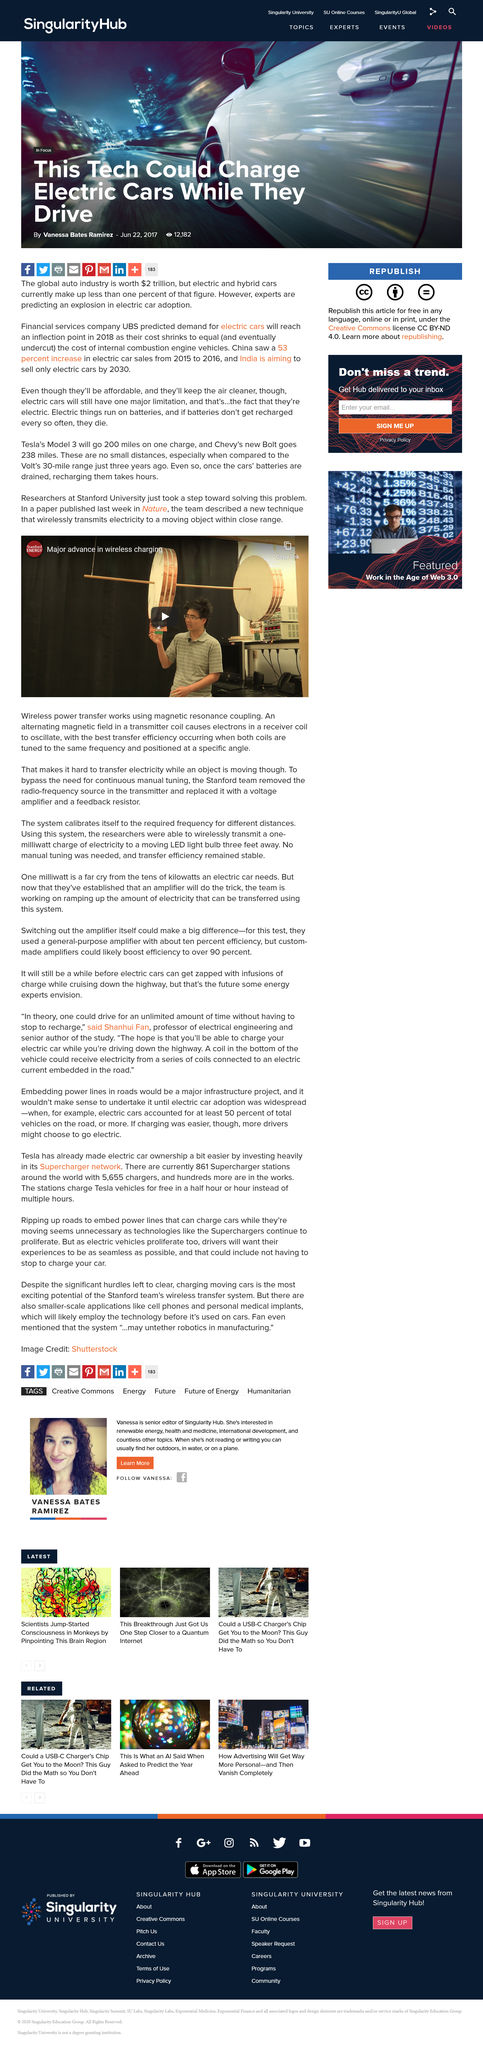Indicate a few pertinent items in this graphic. The video discusses the significant advancements in the field of wireless charging, specifically focusing on how it has been majorly improved over the years. The paper described a technique that wirelessly transmits electricity to a moving object within close range, which allows for the powering of devices without the need for physical contact. Wireless power transfer utilizes magnetic resonance coupling to operate effectively. 